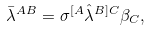<formula> <loc_0><loc_0><loc_500><loc_500>\bar { \lambda } ^ { A B } = \sigma ^ { [ A } \hat { \lambda } ^ { B ] C } \beta _ { C } ,</formula> 